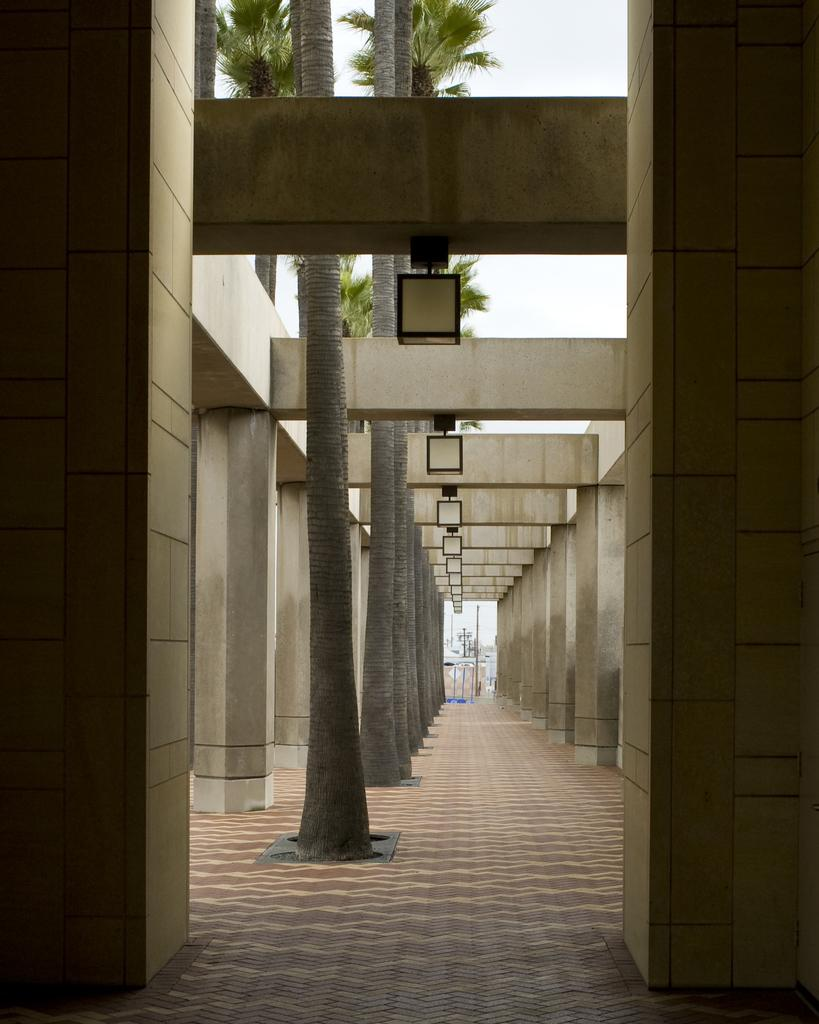What architectural features can be seen in the image? There are pillars in the image. What type of vegetation is present in the image? There are trees in the image. What can be used for illumination in the image? There are lights in the image. What is visible in the background of the image? The sky is visible in the background of the image. What structures can be seen in the background of the image? There are poles in the background of the image. Where is the library located in the image? There is no library present in the image. What type of flame can be seen coming from the trees in the image? There is no flame present in the image; it features trees, pillars, lights, and poles. What is the sack used for in the image? There is no sack present in the image. 